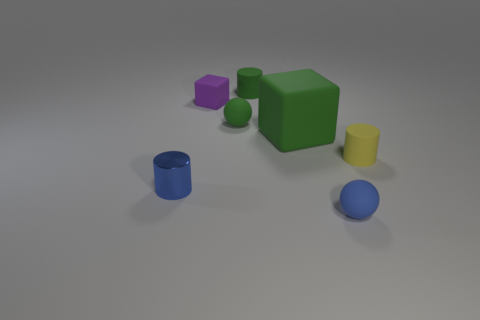Add 1 small yellow things. How many objects exist? 8 Subtract all tiny yellow rubber cylinders. How many cylinders are left? 2 Subtract all yellow cylinders. How many cylinders are left? 2 Subtract all blocks. How many objects are left? 5 Add 2 yellow matte cylinders. How many yellow matte cylinders exist? 3 Subtract 0 red spheres. How many objects are left? 7 Subtract 2 spheres. How many spheres are left? 0 Subtract all yellow cubes. Subtract all blue spheres. How many cubes are left? 2 Subtract all red cubes. How many green cylinders are left? 1 Subtract all tiny cyan shiny cubes. Subtract all small green matte balls. How many objects are left? 6 